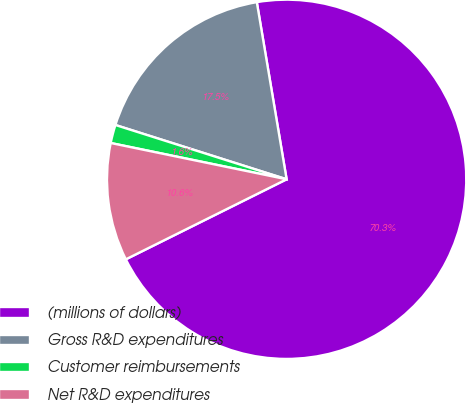Convert chart to OTSL. <chart><loc_0><loc_0><loc_500><loc_500><pie_chart><fcel>(millions of dollars)<fcel>Gross R&D expenditures<fcel>Customer reimbursements<fcel>Net R&D expenditures<nl><fcel>70.31%<fcel>17.46%<fcel>1.65%<fcel>10.59%<nl></chart> 